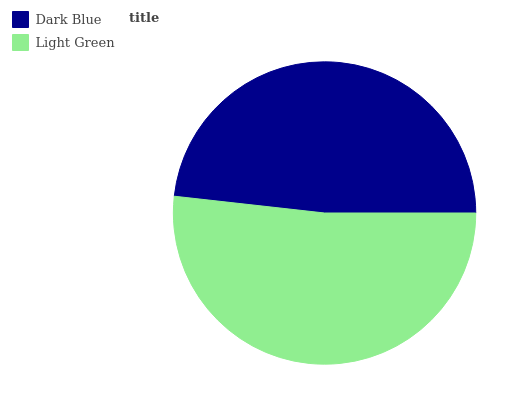Is Dark Blue the minimum?
Answer yes or no. Yes. Is Light Green the maximum?
Answer yes or no. Yes. Is Light Green the minimum?
Answer yes or no. No. Is Light Green greater than Dark Blue?
Answer yes or no. Yes. Is Dark Blue less than Light Green?
Answer yes or no. Yes. Is Dark Blue greater than Light Green?
Answer yes or no. No. Is Light Green less than Dark Blue?
Answer yes or no. No. Is Light Green the high median?
Answer yes or no. Yes. Is Dark Blue the low median?
Answer yes or no. Yes. Is Dark Blue the high median?
Answer yes or no. No. Is Light Green the low median?
Answer yes or no. No. 